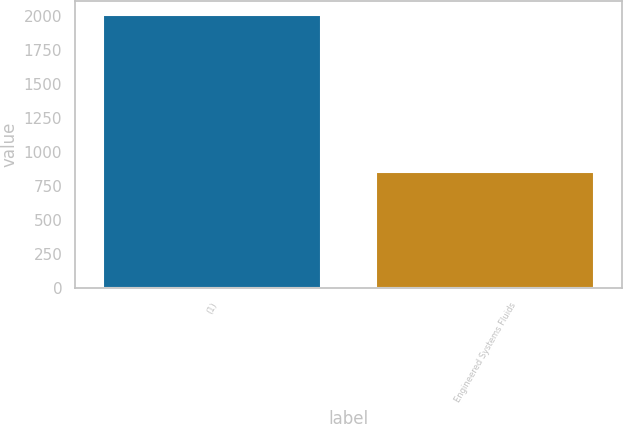Convert chart. <chart><loc_0><loc_0><loc_500><loc_500><bar_chart><fcel>(1)<fcel>Engineered Systems Fluids<nl><fcel>2013<fcel>850<nl></chart> 